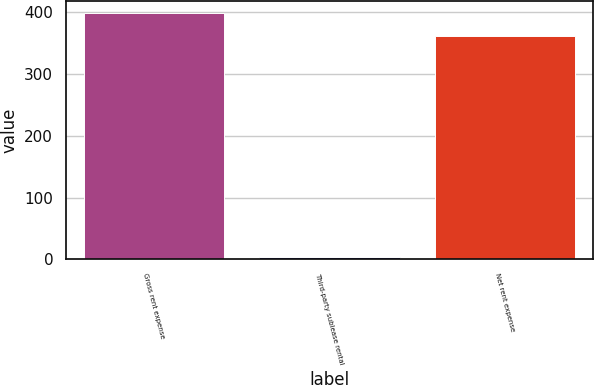Convert chart. <chart><loc_0><loc_0><loc_500><loc_500><bar_chart><fcel>Gross rent expense<fcel>Third-party sublease rental<fcel>Net rent expense<nl><fcel>398.2<fcel>4.1<fcel>362<nl></chart> 